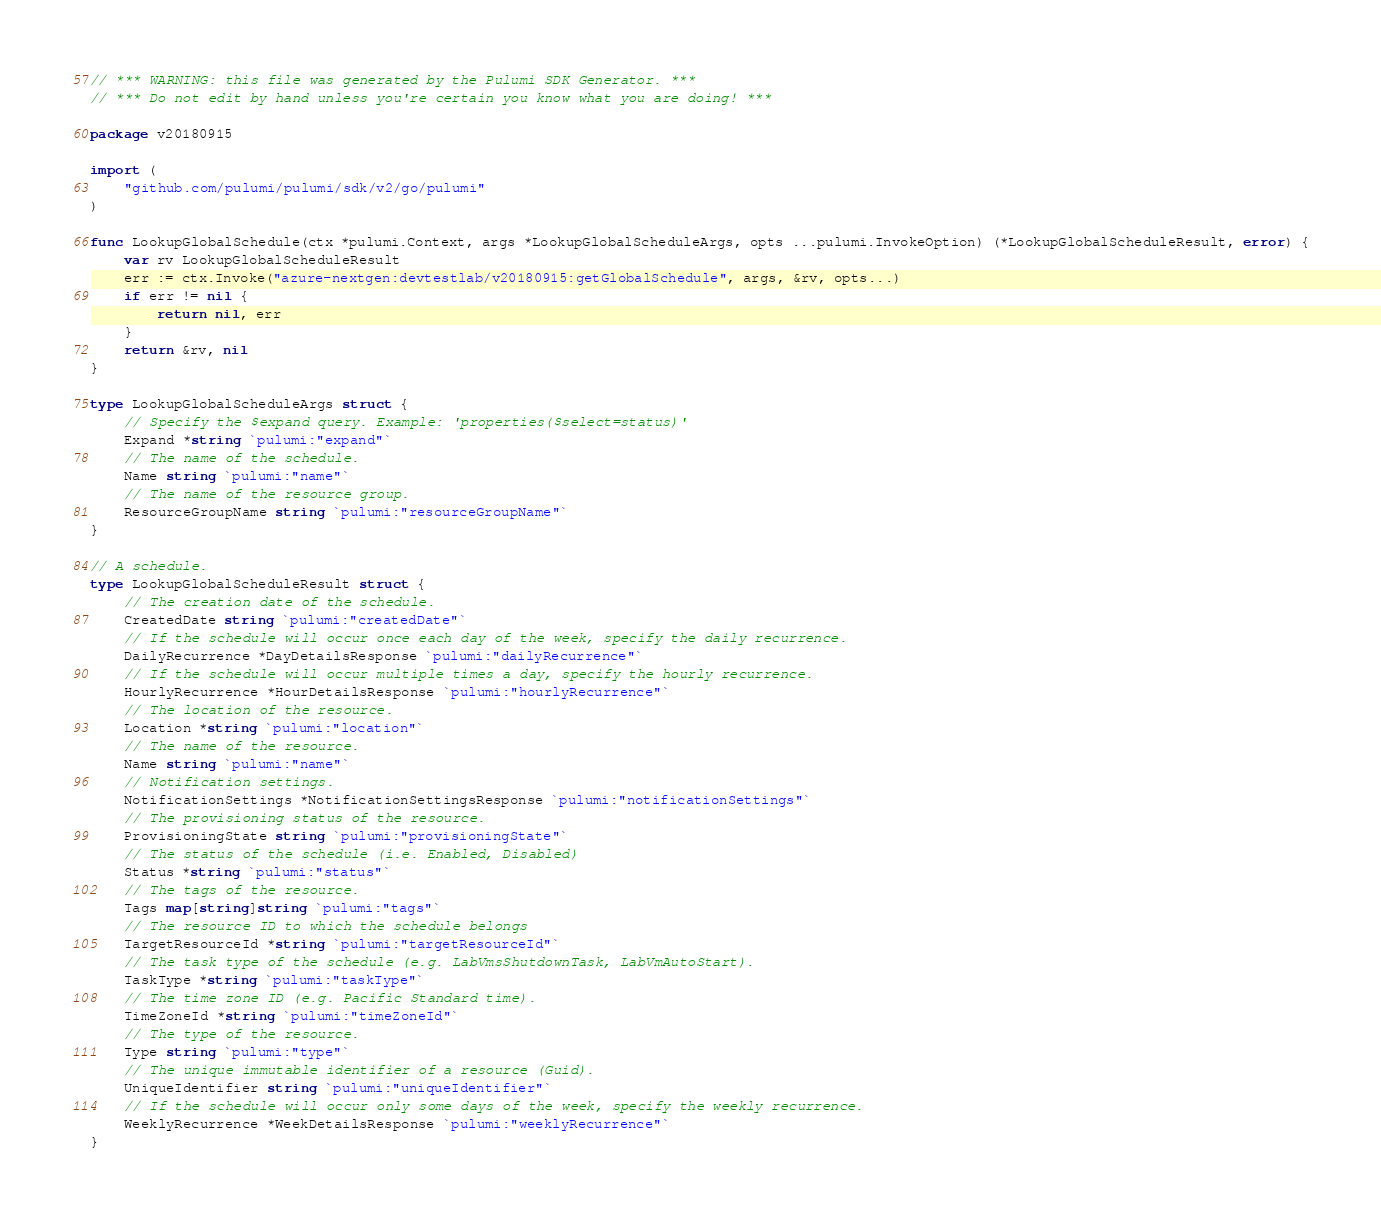<code> <loc_0><loc_0><loc_500><loc_500><_Go_>// *** WARNING: this file was generated by the Pulumi SDK Generator. ***
// *** Do not edit by hand unless you're certain you know what you are doing! ***

package v20180915

import (
	"github.com/pulumi/pulumi/sdk/v2/go/pulumi"
)

func LookupGlobalSchedule(ctx *pulumi.Context, args *LookupGlobalScheduleArgs, opts ...pulumi.InvokeOption) (*LookupGlobalScheduleResult, error) {
	var rv LookupGlobalScheduleResult
	err := ctx.Invoke("azure-nextgen:devtestlab/v20180915:getGlobalSchedule", args, &rv, opts...)
	if err != nil {
		return nil, err
	}
	return &rv, nil
}

type LookupGlobalScheduleArgs struct {
	// Specify the $expand query. Example: 'properties($select=status)'
	Expand *string `pulumi:"expand"`
	// The name of the schedule.
	Name string `pulumi:"name"`
	// The name of the resource group.
	ResourceGroupName string `pulumi:"resourceGroupName"`
}

// A schedule.
type LookupGlobalScheduleResult struct {
	// The creation date of the schedule.
	CreatedDate string `pulumi:"createdDate"`
	// If the schedule will occur once each day of the week, specify the daily recurrence.
	DailyRecurrence *DayDetailsResponse `pulumi:"dailyRecurrence"`
	// If the schedule will occur multiple times a day, specify the hourly recurrence.
	HourlyRecurrence *HourDetailsResponse `pulumi:"hourlyRecurrence"`
	// The location of the resource.
	Location *string `pulumi:"location"`
	// The name of the resource.
	Name string `pulumi:"name"`
	// Notification settings.
	NotificationSettings *NotificationSettingsResponse `pulumi:"notificationSettings"`
	// The provisioning status of the resource.
	ProvisioningState string `pulumi:"provisioningState"`
	// The status of the schedule (i.e. Enabled, Disabled)
	Status *string `pulumi:"status"`
	// The tags of the resource.
	Tags map[string]string `pulumi:"tags"`
	// The resource ID to which the schedule belongs
	TargetResourceId *string `pulumi:"targetResourceId"`
	// The task type of the schedule (e.g. LabVmsShutdownTask, LabVmAutoStart).
	TaskType *string `pulumi:"taskType"`
	// The time zone ID (e.g. Pacific Standard time).
	TimeZoneId *string `pulumi:"timeZoneId"`
	// The type of the resource.
	Type string `pulumi:"type"`
	// The unique immutable identifier of a resource (Guid).
	UniqueIdentifier string `pulumi:"uniqueIdentifier"`
	// If the schedule will occur only some days of the week, specify the weekly recurrence.
	WeeklyRecurrence *WeekDetailsResponse `pulumi:"weeklyRecurrence"`
}
</code> 